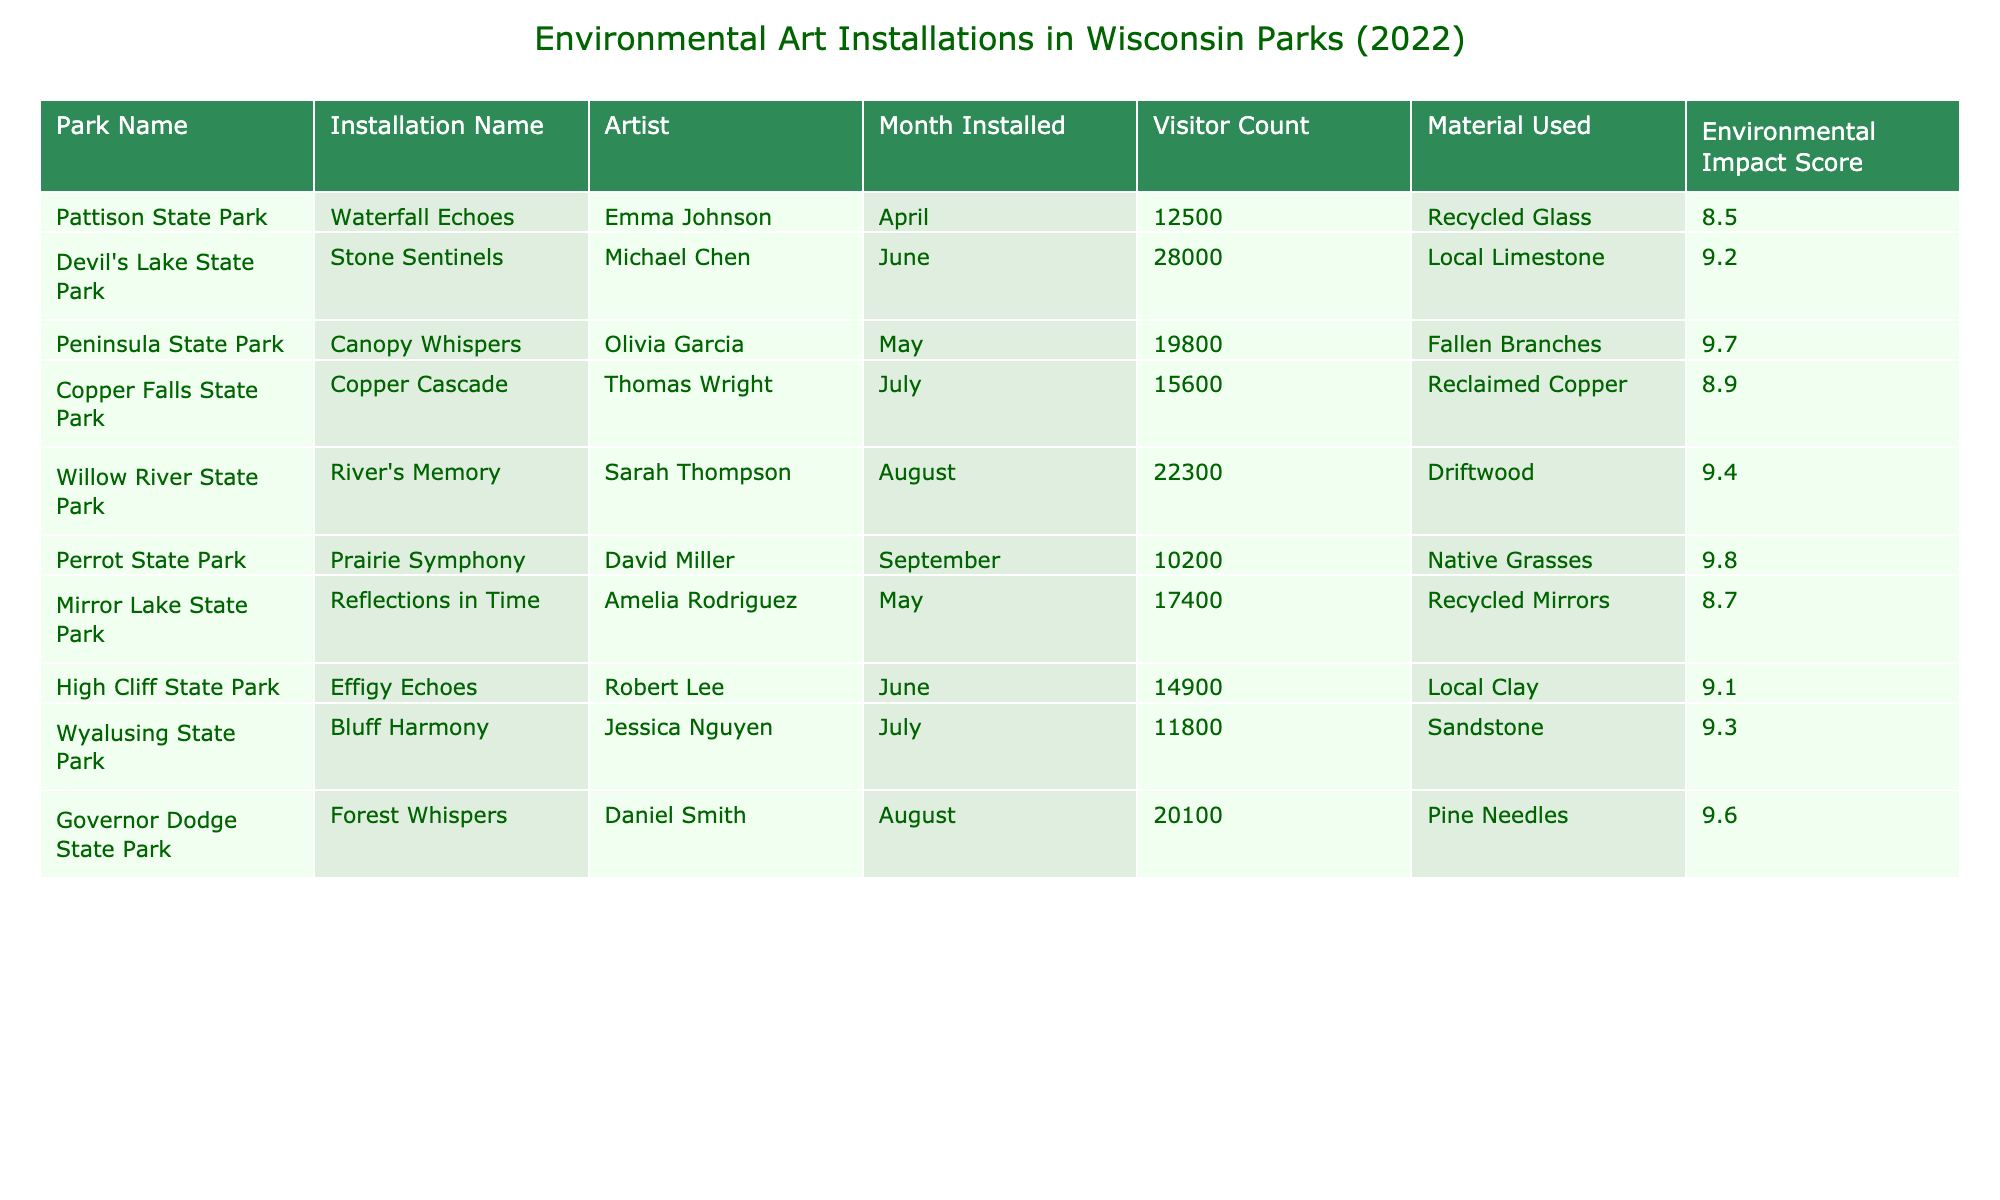What is the highest Environmental Impact Score among the installations? By examining the "Environmental Impact Score" column, the highest score listed is 9.8, associated with "Prairie Symphony" installed at Perrot State Park.
Answer: 9.8 Which installation had the lowest Visitor Count? Looking at the "Visitor Count" column, "Prairie Symphony" at Perrot State Park had the lowest count of 10,200.
Answer: 10,200 Calculate the average Visitor Count for all installations at Wisconsin parks. Summing up all Visitor Counts: 12,500 + 28,000 + 19,800 + 15,600 + 22,300 + 10,200 + 17,400 + 14,900 + 11,800 + 20,100 =  162,600. There are 10 installations, so the average is 162,600 / 10 = 16,260.
Answer: 16,260 Is there any installation that uses Recycled materials? Yes, both "Waterfall Echoes" and "Reflections in Time" use recycled materials: recycled glass and recycled mirrors, respectively.
Answer: Yes Which artist installed at the park with the highest Visitor Count? The installation "Stone Sentinels" by Michael Chen at Devil's Lake State Park had the highest Visitor Count of 28,000. This can be identified by comparing the Visitor Counts in the table for each park.
Answer: Michael Chen What is the total Visitor Count for installations in August? The visitor counts for August installations are: 22,300 (River's Memory) and 20,100 (Forest Whispers). Adding these together results in 22,300 + 20,100 = 42,400.
Answer: 42,400 Which park had an installation made from Driftwood and what was its Environmental Impact Score? "River's Memory" was made from Driftwood at Willow River State Park, having an Environmental Impact Score of 9.4, as reflected in the corresponding columns of the table.
Answer: Willow River State Park, 9.4 Find the difference in Visitor Count between the installations at Devil's Lake State Park and Copper Falls State Park. The Visitor Count at Devil's Lake State Park is 28,000 and at Copper Falls State Park is 15,600. The difference is 28,000 - 15,600 = 12,400.
Answer: 12,400 Which material used has the highest Environmental Impact Score based on the installations? "Native Grasses" used in "Prairie Symphony" has the highest Environmental Impact Score of 9.8 among the materials listed, indicated in the corresponding rows.
Answer: Native Grasses Is there any installation that used Local Clay as the material? Yes, the installation "Effigy Echoes" used Local Clay, as noted in the "Material Used" column.
Answer: Yes 